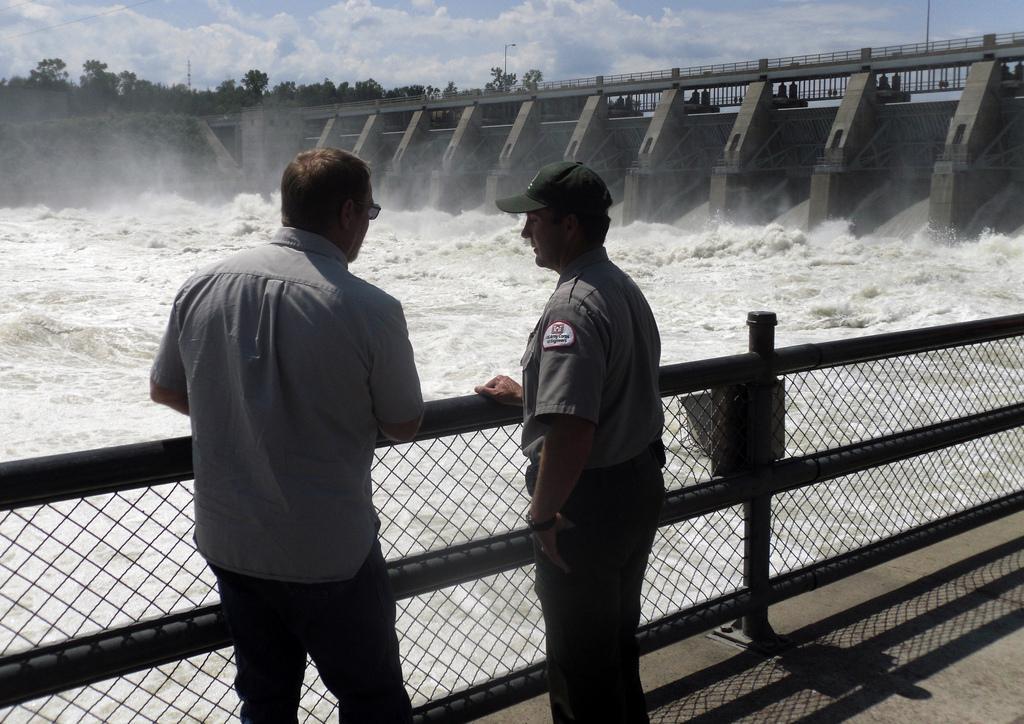Describe this image in one or two sentences. In the foreground of the image there are two persons standing. There is a fencing. In the background of the image there is a dam. There is water. There are trees. 